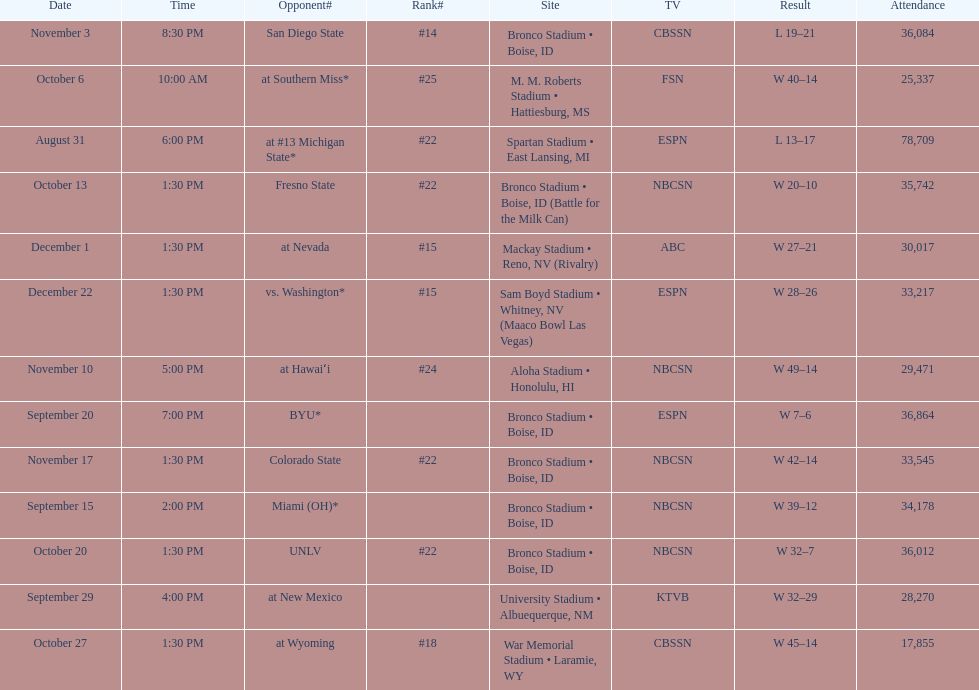What rank was boise state after november 10th? #22. 